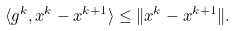Convert formula to latex. <formula><loc_0><loc_0><loc_500><loc_500>\langle g ^ { k } , x ^ { k } - x ^ { k + 1 } \rangle \leq \| x ^ { k } - x ^ { k + 1 } \| .</formula> 